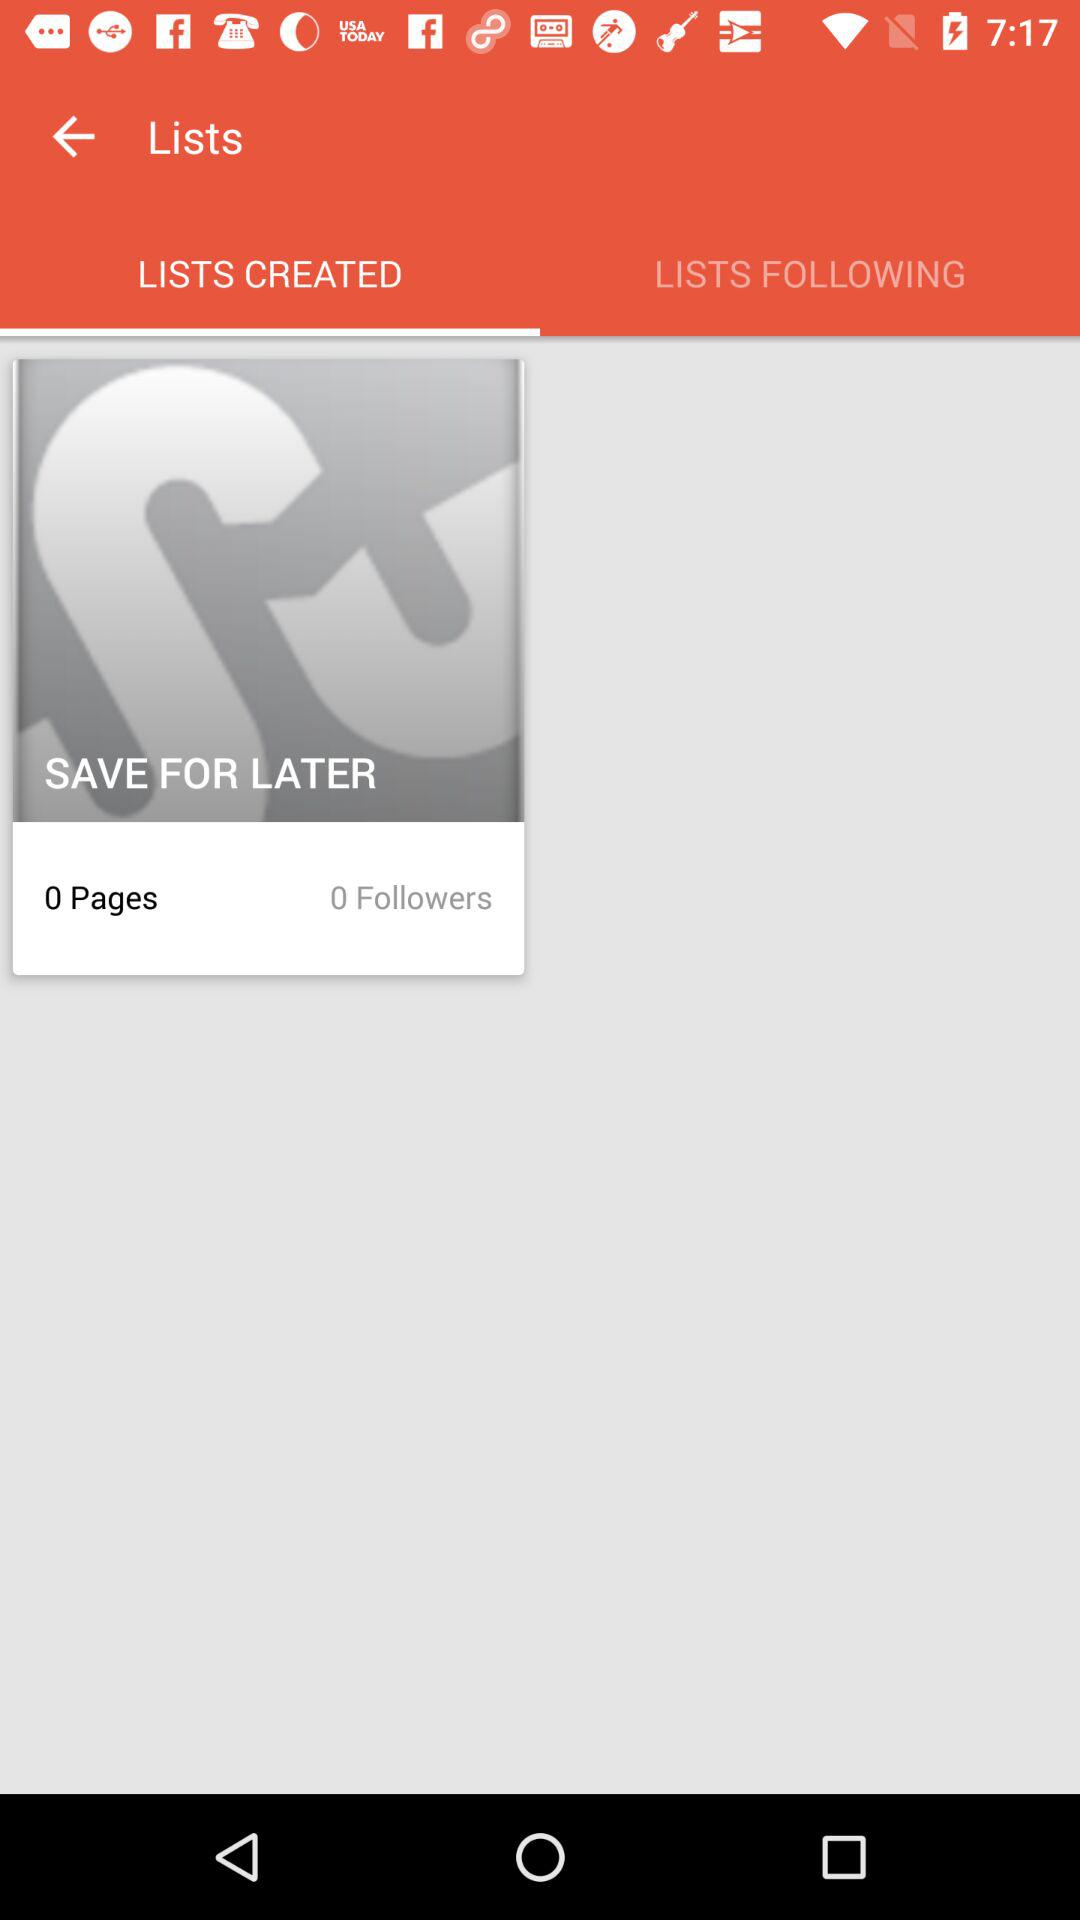How many followers are there? There are 0 followers. 